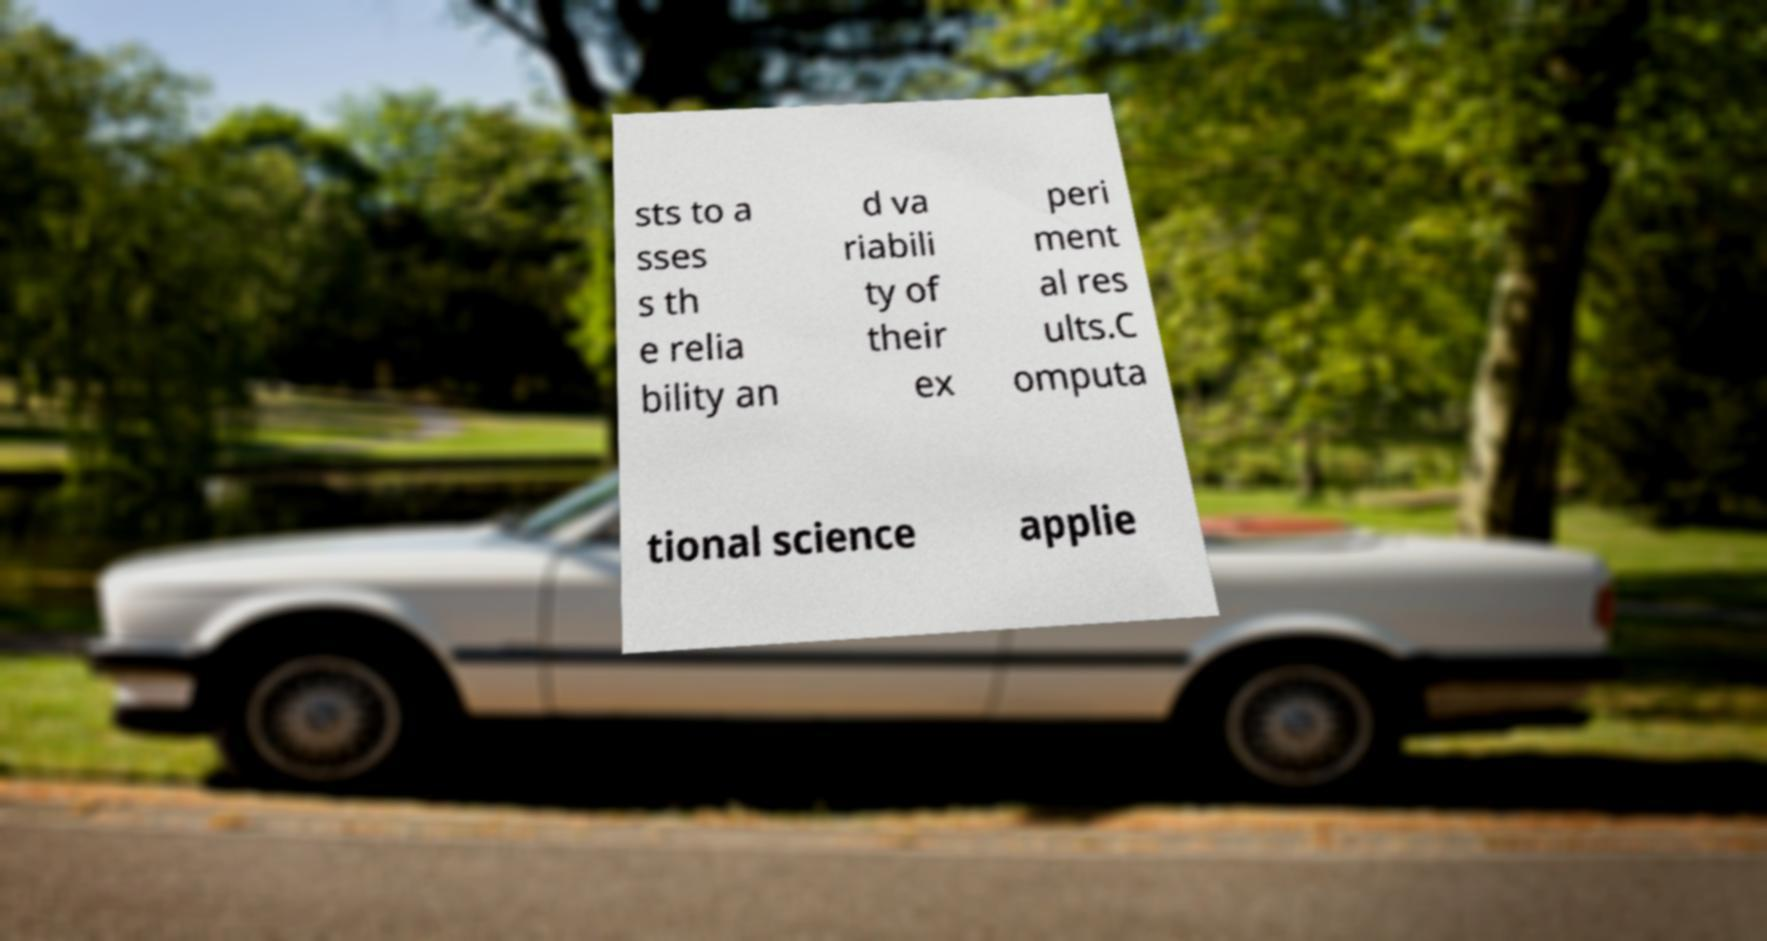What messages or text are displayed in this image? I need them in a readable, typed format. sts to a sses s th e relia bility an d va riabili ty of their ex peri ment al res ults.C omputa tional science applie 